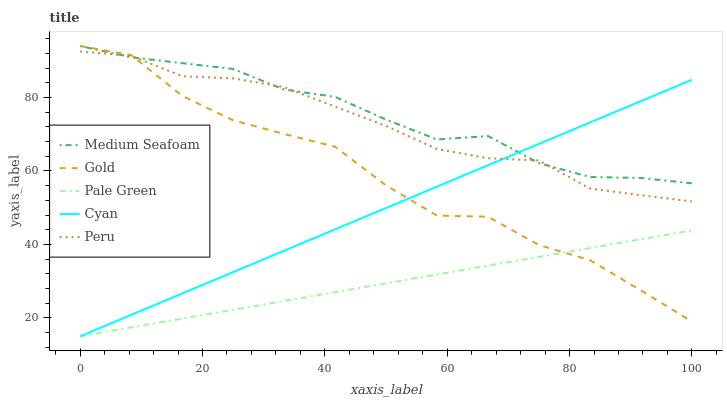Does Cyan have the minimum area under the curve?
Answer yes or no. No. Does Cyan have the maximum area under the curve?
Answer yes or no. No. Is Cyan the smoothest?
Answer yes or no. No. Is Cyan the roughest?
Answer yes or no. No. Does Medium Seafoam have the lowest value?
Answer yes or no. No. Does Cyan have the highest value?
Answer yes or no. No. Is Pale Green less than Peru?
Answer yes or no. Yes. Is Peru greater than Pale Green?
Answer yes or no. Yes. Does Pale Green intersect Peru?
Answer yes or no. No. 